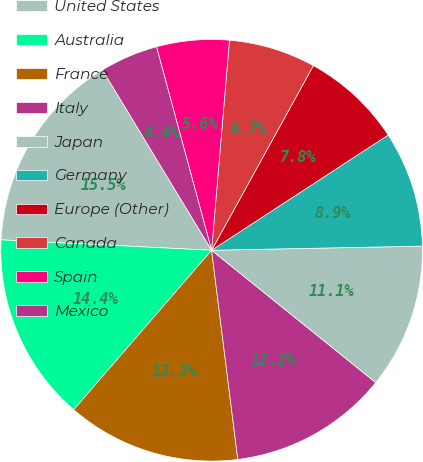Convert chart. <chart><loc_0><loc_0><loc_500><loc_500><pie_chart><fcel>United States<fcel>Australia<fcel>France<fcel>Italy<fcel>Japan<fcel>Germany<fcel>Europe (Other)<fcel>Canada<fcel>Spain<fcel>Mexico<nl><fcel>15.55%<fcel>14.44%<fcel>13.33%<fcel>12.22%<fcel>11.11%<fcel>8.89%<fcel>7.78%<fcel>6.67%<fcel>5.56%<fcel>4.45%<nl></chart> 